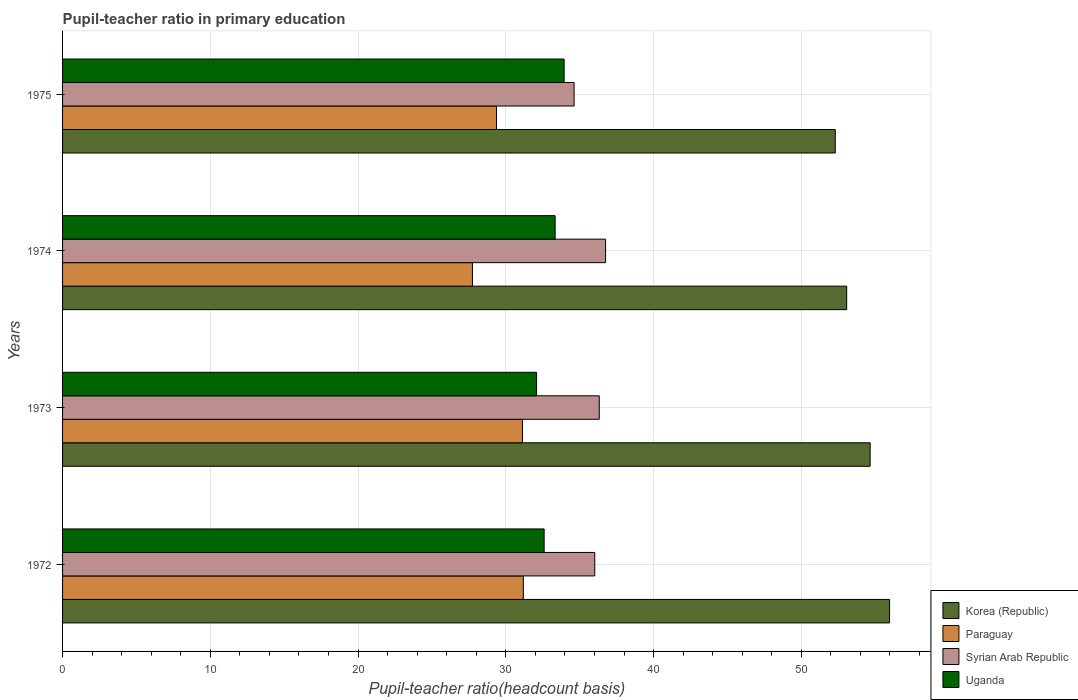How many different coloured bars are there?
Give a very brief answer. 4. How many groups of bars are there?
Keep it short and to the point. 4. Are the number of bars on each tick of the Y-axis equal?
Your response must be concise. Yes. How many bars are there on the 1st tick from the bottom?
Offer a terse response. 4. What is the label of the 3rd group of bars from the top?
Provide a short and direct response. 1973. What is the pupil-teacher ratio in primary education in Uganda in 1973?
Make the answer very short. 32.08. Across all years, what is the maximum pupil-teacher ratio in primary education in Syrian Arab Republic?
Provide a short and direct response. 36.75. Across all years, what is the minimum pupil-teacher ratio in primary education in Paraguay?
Make the answer very short. 27.74. In which year was the pupil-teacher ratio in primary education in Uganda minimum?
Make the answer very short. 1973. What is the total pupil-teacher ratio in primary education in Syrian Arab Republic in the graph?
Give a very brief answer. 143.72. What is the difference between the pupil-teacher ratio in primary education in Paraguay in 1973 and that in 1974?
Your response must be concise. 3.39. What is the difference between the pupil-teacher ratio in primary education in Uganda in 1975 and the pupil-teacher ratio in primary education in Paraguay in 1974?
Your answer should be compact. 6.2. What is the average pupil-teacher ratio in primary education in Paraguay per year?
Provide a short and direct response. 29.86. In the year 1973, what is the difference between the pupil-teacher ratio in primary education in Syrian Arab Republic and pupil-teacher ratio in primary education in Uganda?
Offer a terse response. 4.24. What is the ratio of the pupil-teacher ratio in primary education in Uganda in 1973 to that in 1974?
Offer a terse response. 0.96. What is the difference between the highest and the second highest pupil-teacher ratio in primary education in Uganda?
Your answer should be very brief. 0.61. What is the difference between the highest and the lowest pupil-teacher ratio in primary education in Uganda?
Keep it short and to the point. 1.86. In how many years, is the pupil-teacher ratio in primary education in Korea (Republic) greater than the average pupil-teacher ratio in primary education in Korea (Republic) taken over all years?
Offer a terse response. 2. What does the 2nd bar from the top in 1974 represents?
Offer a terse response. Syrian Arab Republic. What does the 1st bar from the bottom in 1975 represents?
Keep it short and to the point. Korea (Republic). Is it the case that in every year, the sum of the pupil-teacher ratio in primary education in Syrian Arab Republic and pupil-teacher ratio in primary education in Uganda is greater than the pupil-teacher ratio in primary education in Korea (Republic)?
Your answer should be compact. Yes. Are all the bars in the graph horizontal?
Your answer should be compact. Yes. Does the graph contain any zero values?
Your response must be concise. No. Does the graph contain grids?
Provide a succinct answer. Yes. How many legend labels are there?
Keep it short and to the point. 4. What is the title of the graph?
Provide a succinct answer. Pupil-teacher ratio in primary education. What is the label or title of the X-axis?
Offer a very short reply. Pupil-teacher ratio(headcount basis). What is the label or title of the Y-axis?
Provide a short and direct response. Years. What is the Pupil-teacher ratio(headcount basis) in Korea (Republic) in 1972?
Ensure brevity in your answer.  55.97. What is the Pupil-teacher ratio(headcount basis) in Paraguay in 1972?
Offer a very short reply. 31.19. What is the Pupil-teacher ratio(headcount basis) of Syrian Arab Republic in 1972?
Provide a short and direct response. 36.02. What is the Pupil-teacher ratio(headcount basis) of Uganda in 1972?
Give a very brief answer. 32.59. What is the Pupil-teacher ratio(headcount basis) of Korea (Republic) in 1973?
Ensure brevity in your answer.  54.66. What is the Pupil-teacher ratio(headcount basis) of Paraguay in 1973?
Your answer should be compact. 31.13. What is the Pupil-teacher ratio(headcount basis) of Syrian Arab Republic in 1973?
Keep it short and to the point. 36.32. What is the Pupil-teacher ratio(headcount basis) in Uganda in 1973?
Give a very brief answer. 32.08. What is the Pupil-teacher ratio(headcount basis) of Korea (Republic) in 1974?
Offer a very short reply. 53.07. What is the Pupil-teacher ratio(headcount basis) in Paraguay in 1974?
Provide a short and direct response. 27.74. What is the Pupil-teacher ratio(headcount basis) in Syrian Arab Republic in 1974?
Your answer should be very brief. 36.75. What is the Pupil-teacher ratio(headcount basis) in Uganda in 1974?
Your answer should be compact. 33.34. What is the Pupil-teacher ratio(headcount basis) in Korea (Republic) in 1975?
Your answer should be compact. 52.3. What is the Pupil-teacher ratio(headcount basis) in Paraguay in 1975?
Your response must be concise. 29.37. What is the Pupil-teacher ratio(headcount basis) of Syrian Arab Republic in 1975?
Make the answer very short. 34.62. What is the Pupil-teacher ratio(headcount basis) in Uganda in 1975?
Ensure brevity in your answer.  33.95. Across all years, what is the maximum Pupil-teacher ratio(headcount basis) of Korea (Republic)?
Your answer should be very brief. 55.97. Across all years, what is the maximum Pupil-teacher ratio(headcount basis) in Paraguay?
Make the answer very short. 31.19. Across all years, what is the maximum Pupil-teacher ratio(headcount basis) in Syrian Arab Republic?
Make the answer very short. 36.75. Across all years, what is the maximum Pupil-teacher ratio(headcount basis) of Uganda?
Make the answer very short. 33.95. Across all years, what is the minimum Pupil-teacher ratio(headcount basis) in Korea (Republic)?
Offer a very short reply. 52.3. Across all years, what is the minimum Pupil-teacher ratio(headcount basis) in Paraguay?
Ensure brevity in your answer.  27.74. Across all years, what is the minimum Pupil-teacher ratio(headcount basis) of Syrian Arab Republic?
Offer a terse response. 34.62. Across all years, what is the minimum Pupil-teacher ratio(headcount basis) of Uganda?
Offer a terse response. 32.08. What is the total Pupil-teacher ratio(headcount basis) in Korea (Republic) in the graph?
Give a very brief answer. 216. What is the total Pupil-teacher ratio(headcount basis) of Paraguay in the graph?
Your answer should be very brief. 119.42. What is the total Pupil-teacher ratio(headcount basis) of Syrian Arab Republic in the graph?
Provide a succinct answer. 143.72. What is the total Pupil-teacher ratio(headcount basis) of Uganda in the graph?
Your response must be concise. 131.96. What is the difference between the Pupil-teacher ratio(headcount basis) in Korea (Republic) in 1972 and that in 1973?
Make the answer very short. 1.31. What is the difference between the Pupil-teacher ratio(headcount basis) in Paraguay in 1972 and that in 1973?
Offer a terse response. 0.06. What is the difference between the Pupil-teacher ratio(headcount basis) of Syrian Arab Republic in 1972 and that in 1973?
Keep it short and to the point. -0.3. What is the difference between the Pupil-teacher ratio(headcount basis) of Uganda in 1972 and that in 1973?
Your answer should be compact. 0.51. What is the difference between the Pupil-teacher ratio(headcount basis) in Korea (Republic) in 1972 and that in 1974?
Ensure brevity in your answer.  2.9. What is the difference between the Pupil-teacher ratio(headcount basis) of Paraguay in 1972 and that in 1974?
Give a very brief answer. 3.44. What is the difference between the Pupil-teacher ratio(headcount basis) in Syrian Arab Republic in 1972 and that in 1974?
Provide a succinct answer. -0.73. What is the difference between the Pupil-teacher ratio(headcount basis) in Uganda in 1972 and that in 1974?
Provide a succinct answer. -0.75. What is the difference between the Pupil-teacher ratio(headcount basis) of Korea (Republic) in 1972 and that in 1975?
Your response must be concise. 3.67. What is the difference between the Pupil-teacher ratio(headcount basis) of Paraguay in 1972 and that in 1975?
Provide a short and direct response. 1.81. What is the difference between the Pupil-teacher ratio(headcount basis) in Syrian Arab Republic in 1972 and that in 1975?
Your answer should be very brief. 1.4. What is the difference between the Pupil-teacher ratio(headcount basis) of Uganda in 1972 and that in 1975?
Provide a short and direct response. -1.35. What is the difference between the Pupil-teacher ratio(headcount basis) of Korea (Republic) in 1973 and that in 1974?
Offer a very short reply. 1.59. What is the difference between the Pupil-teacher ratio(headcount basis) of Paraguay in 1973 and that in 1974?
Provide a succinct answer. 3.39. What is the difference between the Pupil-teacher ratio(headcount basis) of Syrian Arab Republic in 1973 and that in 1974?
Provide a short and direct response. -0.43. What is the difference between the Pupil-teacher ratio(headcount basis) of Uganda in 1973 and that in 1974?
Offer a very short reply. -1.26. What is the difference between the Pupil-teacher ratio(headcount basis) of Korea (Republic) in 1973 and that in 1975?
Provide a short and direct response. 2.36. What is the difference between the Pupil-teacher ratio(headcount basis) of Paraguay in 1973 and that in 1975?
Keep it short and to the point. 1.76. What is the difference between the Pupil-teacher ratio(headcount basis) in Syrian Arab Republic in 1973 and that in 1975?
Your answer should be very brief. 1.7. What is the difference between the Pupil-teacher ratio(headcount basis) in Uganda in 1973 and that in 1975?
Make the answer very short. -1.86. What is the difference between the Pupil-teacher ratio(headcount basis) of Korea (Republic) in 1974 and that in 1975?
Your answer should be compact. 0.77. What is the difference between the Pupil-teacher ratio(headcount basis) in Paraguay in 1974 and that in 1975?
Offer a very short reply. -1.63. What is the difference between the Pupil-teacher ratio(headcount basis) in Syrian Arab Republic in 1974 and that in 1975?
Offer a terse response. 2.13. What is the difference between the Pupil-teacher ratio(headcount basis) of Uganda in 1974 and that in 1975?
Give a very brief answer. -0.61. What is the difference between the Pupil-teacher ratio(headcount basis) of Korea (Republic) in 1972 and the Pupil-teacher ratio(headcount basis) of Paraguay in 1973?
Keep it short and to the point. 24.84. What is the difference between the Pupil-teacher ratio(headcount basis) of Korea (Republic) in 1972 and the Pupil-teacher ratio(headcount basis) of Syrian Arab Republic in 1973?
Make the answer very short. 19.65. What is the difference between the Pupil-teacher ratio(headcount basis) of Korea (Republic) in 1972 and the Pupil-teacher ratio(headcount basis) of Uganda in 1973?
Offer a terse response. 23.89. What is the difference between the Pupil-teacher ratio(headcount basis) of Paraguay in 1972 and the Pupil-teacher ratio(headcount basis) of Syrian Arab Republic in 1973?
Make the answer very short. -5.14. What is the difference between the Pupil-teacher ratio(headcount basis) of Paraguay in 1972 and the Pupil-teacher ratio(headcount basis) of Uganda in 1973?
Offer a terse response. -0.9. What is the difference between the Pupil-teacher ratio(headcount basis) of Syrian Arab Republic in 1972 and the Pupil-teacher ratio(headcount basis) of Uganda in 1973?
Offer a terse response. 3.94. What is the difference between the Pupil-teacher ratio(headcount basis) of Korea (Republic) in 1972 and the Pupil-teacher ratio(headcount basis) of Paraguay in 1974?
Your answer should be very brief. 28.23. What is the difference between the Pupil-teacher ratio(headcount basis) of Korea (Republic) in 1972 and the Pupil-teacher ratio(headcount basis) of Syrian Arab Republic in 1974?
Give a very brief answer. 19.22. What is the difference between the Pupil-teacher ratio(headcount basis) in Korea (Republic) in 1972 and the Pupil-teacher ratio(headcount basis) in Uganda in 1974?
Keep it short and to the point. 22.63. What is the difference between the Pupil-teacher ratio(headcount basis) of Paraguay in 1972 and the Pupil-teacher ratio(headcount basis) of Syrian Arab Republic in 1974?
Ensure brevity in your answer.  -5.57. What is the difference between the Pupil-teacher ratio(headcount basis) of Paraguay in 1972 and the Pupil-teacher ratio(headcount basis) of Uganda in 1974?
Offer a very short reply. -2.15. What is the difference between the Pupil-teacher ratio(headcount basis) of Syrian Arab Republic in 1972 and the Pupil-teacher ratio(headcount basis) of Uganda in 1974?
Provide a succinct answer. 2.68. What is the difference between the Pupil-teacher ratio(headcount basis) in Korea (Republic) in 1972 and the Pupil-teacher ratio(headcount basis) in Paraguay in 1975?
Make the answer very short. 26.6. What is the difference between the Pupil-teacher ratio(headcount basis) of Korea (Republic) in 1972 and the Pupil-teacher ratio(headcount basis) of Syrian Arab Republic in 1975?
Make the answer very short. 21.35. What is the difference between the Pupil-teacher ratio(headcount basis) of Korea (Republic) in 1972 and the Pupil-teacher ratio(headcount basis) of Uganda in 1975?
Keep it short and to the point. 22.03. What is the difference between the Pupil-teacher ratio(headcount basis) in Paraguay in 1972 and the Pupil-teacher ratio(headcount basis) in Syrian Arab Republic in 1975?
Make the answer very short. -3.44. What is the difference between the Pupil-teacher ratio(headcount basis) in Paraguay in 1972 and the Pupil-teacher ratio(headcount basis) in Uganda in 1975?
Offer a very short reply. -2.76. What is the difference between the Pupil-teacher ratio(headcount basis) of Syrian Arab Republic in 1972 and the Pupil-teacher ratio(headcount basis) of Uganda in 1975?
Offer a very short reply. 2.07. What is the difference between the Pupil-teacher ratio(headcount basis) of Korea (Republic) in 1973 and the Pupil-teacher ratio(headcount basis) of Paraguay in 1974?
Give a very brief answer. 26.92. What is the difference between the Pupil-teacher ratio(headcount basis) of Korea (Republic) in 1973 and the Pupil-teacher ratio(headcount basis) of Syrian Arab Republic in 1974?
Provide a succinct answer. 17.91. What is the difference between the Pupil-teacher ratio(headcount basis) of Korea (Republic) in 1973 and the Pupil-teacher ratio(headcount basis) of Uganda in 1974?
Give a very brief answer. 21.32. What is the difference between the Pupil-teacher ratio(headcount basis) in Paraguay in 1973 and the Pupil-teacher ratio(headcount basis) in Syrian Arab Republic in 1974?
Your answer should be very brief. -5.63. What is the difference between the Pupil-teacher ratio(headcount basis) in Paraguay in 1973 and the Pupil-teacher ratio(headcount basis) in Uganda in 1974?
Make the answer very short. -2.21. What is the difference between the Pupil-teacher ratio(headcount basis) in Syrian Arab Republic in 1973 and the Pupil-teacher ratio(headcount basis) in Uganda in 1974?
Provide a short and direct response. 2.99. What is the difference between the Pupil-teacher ratio(headcount basis) of Korea (Republic) in 1973 and the Pupil-teacher ratio(headcount basis) of Paraguay in 1975?
Give a very brief answer. 25.29. What is the difference between the Pupil-teacher ratio(headcount basis) in Korea (Republic) in 1973 and the Pupil-teacher ratio(headcount basis) in Syrian Arab Republic in 1975?
Your answer should be very brief. 20.04. What is the difference between the Pupil-teacher ratio(headcount basis) in Korea (Republic) in 1973 and the Pupil-teacher ratio(headcount basis) in Uganda in 1975?
Provide a short and direct response. 20.71. What is the difference between the Pupil-teacher ratio(headcount basis) in Paraguay in 1973 and the Pupil-teacher ratio(headcount basis) in Syrian Arab Republic in 1975?
Your answer should be very brief. -3.49. What is the difference between the Pupil-teacher ratio(headcount basis) in Paraguay in 1973 and the Pupil-teacher ratio(headcount basis) in Uganda in 1975?
Your response must be concise. -2.82. What is the difference between the Pupil-teacher ratio(headcount basis) in Syrian Arab Republic in 1973 and the Pupil-teacher ratio(headcount basis) in Uganda in 1975?
Your answer should be compact. 2.38. What is the difference between the Pupil-teacher ratio(headcount basis) in Korea (Republic) in 1974 and the Pupil-teacher ratio(headcount basis) in Paraguay in 1975?
Your answer should be very brief. 23.7. What is the difference between the Pupil-teacher ratio(headcount basis) in Korea (Republic) in 1974 and the Pupil-teacher ratio(headcount basis) in Syrian Arab Republic in 1975?
Offer a terse response. 18.45. What is the difference between the Pupil-teacher ratio(headcount basis) of Korea (Republic) in 1974 and the Pupil-teacher ratio(headcount basis) of Uganda in 1975?
Your response must be concise. 19.12. What is the difference between the Pupil-teacher ratio(headcount basis) of Paraguay in 1974 and the Pupil-teacher ratio(headcount basis) of Syrian Arab Republic in 1975?
Offer a very short reply. -6.88. What is the difference between the Pupil-teacher ratio(headcount basis) in Paraguay in 1974 and the Pupil-teacher ratio(headcount basis) in Uganda in 1975?
Offer a terse response. -6.2. What is the difference between the Pupil-teacher ratio(headcount basis) in Syrian Arab Republic in 1974 and the Pupil-teacher ratio(headcount basis) in Uganda in 1975?
Give a very brief answer. 2.81. What is the average Pupil-teacher ratio(headcount basis) in Korea (Republic) per year?
Give a very brief answer. 54. What is the average Pupil-teacher ratio(headcount basis) in Paraguay per year?
Provide a short and direct response. 29.86. What is the average Pupil-teacher ratio(headcount basis) of Syrian Arab Republic per year?
Your response must be concise. 35.93. What is the average Pupil-teacher ratio(headcount basis) of Uganda per year?
Your response must be concise. 32.99. In the year 1972, what is the difference between the Pupil-teacher ratio(headcount basis) in Korea (Republic) and Pupil-teacher ratio(headcount basis) in Paraguay?
Ensure brevity in your answer.  24.79. In the year 1972, what is the difference between the Pupil-teacher ratio(headcount basis) in Korea (Republic) and Pupil-teacher ratio(headcount basis) in Syrian Arab Republic?
Your answer should be compact. 19.95. In the year 1972, what is the difference between the Pupil-teacher ratio(headcount basis) in Korea (Republic) and Pupil-teacher ratio(headcount basis) in Uganda?
Make the answer very short. 23.38. In the year 1972, what is the difference between the Pupil-teacher ratio(headcount basis) of Paraguay and Pupil-teacher ratio(headcount basis) of Syrian Arab Republic?
Offer a terse response. -4.83. In the year 1972, what is the difference between the Pupil-teacher ratio(headcount basis) in Paraguay and Pupil-teacher ratio(headcount basis) in Uganda?
Keep it short and to the point. -1.41. In the year 1972, what is the difference between the Pupil-teacher ratio(headcount basis) of Syrian Arab Republic and Pupil-teacher ratio(headcount basis) of Uganda?
Provide a succinct answer. 3.43. In the year 1973, what is the difference between the Pupil-teacher ratio(headcount basis) of Korea (Republic) and Pupil-teacher ratio(headcount basis) of Paraguay?
Your answer should be very brief. 23.53. In the year 1973, what is the difference between the Pupil-teacher ratio(headcount basis) of Korea (Republic) and Pupil-teacher ratio(headcount basis) of Syrian Arab Republic?
Keep it short and to the point. 18.33. In the year 1973, what is the difference between the Pupil-teacher ratio(headcount basis) in Korea (Republic) and Pupil-teacher ratio(headcount basis) in Uganda?
Your answer should be compact. 22.58. In the year 1973, what is the difference between the Pupil-teacher ratio(headcount basis) in Paraguay and Pupil-teacher ratio(headcount basis) in Syrian Arab Republic?
Your response must be concise. -5.2. In the year 1973, what is the difference between the Pupil-teacher ratio(headcount basis) of Paraguay and Pupil-teacher ratio(headcount basis) of Uganda?
Your answer should be compact. -0.95. In the year 1973, what is the difference between the Pupil-teacher ratio(headcount basis) of Syrian Arab Republic and Pupil-teacher ratio(headcount basis) of Uganda?
Your response must be concise. 4.24. In the year 1974, what is the difference between the Pupil-teacher ratio(headcount basis) in Korea (Republic) and Pupil-teacher ratio(headcount basis) in Paraguay?
Your response must be concise. 25.33. In the year 1974, what is the difference between the Pupil-teacher ratio(headcount basis) of Korea (Republic) and Pupil-teacher ratio(headcount basis) of Syrian Arab Republic?
Provide a short and direct response. 16.32. In the year 1974, what is the difference between the Pupil-teacher ratio(headcount basis) in Korea (Republic) and Pupil-teacher ratio(headcount basis) in Uganda?
Provide a succinct answer. 19.73. In the year 1974, what is the difference between the Pupil-teacher ratio(headcount basis) of Paraguay and Pupil-teacher ratio(headcount basis) of Syrian Arab Republic?
Provide a short and direct response. -9.01. In the year 1974, what is the difference between the Pupil-teacher ratio(headcount basis) of Paraguay and Pupil-teacher ratio(headcount basis) of Uganda?
Make the answer very short. -5.6. In the year 1974, what is the difference between the Pupil-teacher ratio(headcount basis) of Syrian Arab Republic and Pupil-teacher ratio(headcount basis) of Uganda?
Your answer should be compact. 3.41. In the year 1975, what is the difference between the Pupil-teacher ratio(headcount basis) of Korea (Republic) and Pupil-teacher ratio(headcount basis) of Paraguay?
Your response must be concise. 22.93. In the year 1975, what is the difference between the Pupil-teacher ratio(headcount basis) of Korea (Republic) and Pupil-teacher ratio(headcount basis) of Syrian Arab Republic?
Your answer should be compact. 17.68. In the year 1975, what is the difference between the Pupil-teacher ratio(headcount basis) of Korea (Republic) and Pupil-teacher ratio(headcount basis) of Uganda?
Offer a very short reply. 18.35. In the year 1975, what is the difference between the Pupil-teacher ratio(headcount basis) in Paraguay and Pupil-teacher ratio(headcount basis) in Syrian Arab Republic?
Your answer should be compact. -5.25. In the year 1975, what is the difference between the Pupil-teacher ratio(headcount basis) of Paraguay and Pupil-teacher ratio(headcount basis) of Uganda?
Ensure brevity in your answer.  -4.58. In the year 1975, what is the difference between the Pupil-teacher ratio(headcount basis) of Syrian Arab Republic and Pupil-teacher ratio(headcount basis) of Uganda?
Provide a succinct answer. 0.68. What is the ratio of the Pupil-teacher ratio(headcount basis) of Korea (Republic) in 1972 to that in 1973?
Provide a short and direct response. 1.02. What is the ratio of the Pupil-teacher ratio(headcount basis) in Paraguay in 1972 to that in 1973?
Provide a succinct answer. 1. What is the ratio of the Pupil-teacher ratio(headcount basis) of Syrian Arab Republic in 1972 to that in 1973?
Offer a terse response. 0.99. What is the ratio of the Pupil-teacher ratio(headcount basis) of Korea (Republic) in 1972 to that in 1974?
Offer a terse response. 1.05. What is the ratio of the Pupil-teacher ratio(headcount basis) of Paraguay in 1972 to that in 1974?
Ensure brevity in your answer.  1.12. What is the ratio of the Pupil-teacher ratio(headcount basis) of Syrian Arab Republic in 1972 to that in 1974?
Your answer should be very brief. 0.98. What is the ratio of the Pupil-teacher ratio(headcount basis) of Uganda in 1972 to that in 1974?
Your answer should be compact. 0.98. What is the ratio of the Pupil-teacher ratio(headcount basis) of Korea (Republic) in 1972 to that in 1975?
Offer a very short reply. 1.07. What is the ratio of the Pupil-teacher ratio(headcount basis) of Paraguay in 1972 to that in 1975?
Provide a short and direct response. 1.06. What is the ratio of the Pupil-teacher ratio(headcount basis) of Syrian Arab Republic in 1972 to that in 1975?
Your answer should be compact. 1.04. What is the ratio of the Pupil-teacher ratio(headcount basis) of Uganda in 1972 to that in 1975?
Offer a very short reply. 0.96. What is the ratio of the Pupil-teacher ratio(headcount basis) of Korea (Republic) in 1973 to that in 1974?
Your answer should be compact. 1.03. What is the ratio of the Pupil-teacher ratio(headcount basis) of Paraguay in 1973 to that in 1974?
Give a very brief answer. 1.12. What is the ratio of the Pupil-teacher ratio(headcount basis) of Syrian Arab Republic in 1973 to that in 1974?
Offer a terse response. 0.99. What is the ratio of the Pupil-teacher ratio(headcount basis) of Uganda in 1973 to that in 1974?
Your answer should be compact. 0.96. What is the ratio of the Pupil-teacher ratio(headcount basis) of Korea (Republic) in 1973 to that in 1975?
Offer a terse response. 1.05. What is the ratio of the Pupil-teacher ratio(headcount basis) in Paraguay in 1973 to that in 1975?
Offer a terse response. 1.06. What is the ratio of the Pupil-teacher ratio(headcount basis) of Syrian Arab Republic in 1973 to that in 1975?
Your response must be concise. 1.05. What is the ratio of the Pupil-teacher ratio(headcount basis) in Uganda in 1973 to that in 1975?
Ensure brevity in your answer.  0.95. What is the ratio of the Pupil-teacher ratio(headcount basis) in Korea (Republic) in 1974 to that in 1975?
Provide a short and direct response. 1.01. What is the ratio of the Pupil-teacher ratio(headcount basis) of Paraguay in 1974 to that in 1975?
Your answer should be compact. 0.94. What is the ratio of the Pupil-teacher ratio(headcount basis) of Syrian Arab Republic in 1974 to that in 1975?
Provide a short and direct response. 1.06. What is the ratio of the Pupil-teacher ratio(headcount basis) in Uganda in 1974 to that in 1975?
Your answer should be very brief. 0.98. What is the difference between the highest and the second highest Pupil-teacher ratio(headcount basis) of Korea (Republic)?
Ensure brevity in your answer.  1.31. What is the difference between the highest and the second highest Pupil-teacher ratio(headcount basis) in Paraguay?
Make the answer very short. 0.06. What is the difference between the highest and the second highest Pupil-teacher ratio(headcount basis) in Syrian Arab Republic?
Provide a short and direct response. 0.43. What is the difference between the highest and the second highest Pupil-teacher ratio(headcount basis) of Uganda?
Your response must be concise. 0.61. What is the difference between the highest and the lowest Pupil-teacher ratio(headcount basis) in Korea (Republic)?
Make the answer very short. 3.67. What is the difference between the highest and the lowest Pupil-teacher ratio(headcount basis) of Paraguay?
Your answer should be very brief. 3.44. What is the difference between the highest and the lowest Pupil-teacher ratio(headcount basis) of Syrian Arab Republic?
Your answer should be very brief. 2.13. What is the difference between the highest and the lowest Pupil-teacher ratio(headcount basis) in Uganda?
Your answer should be compact. 1.86. 